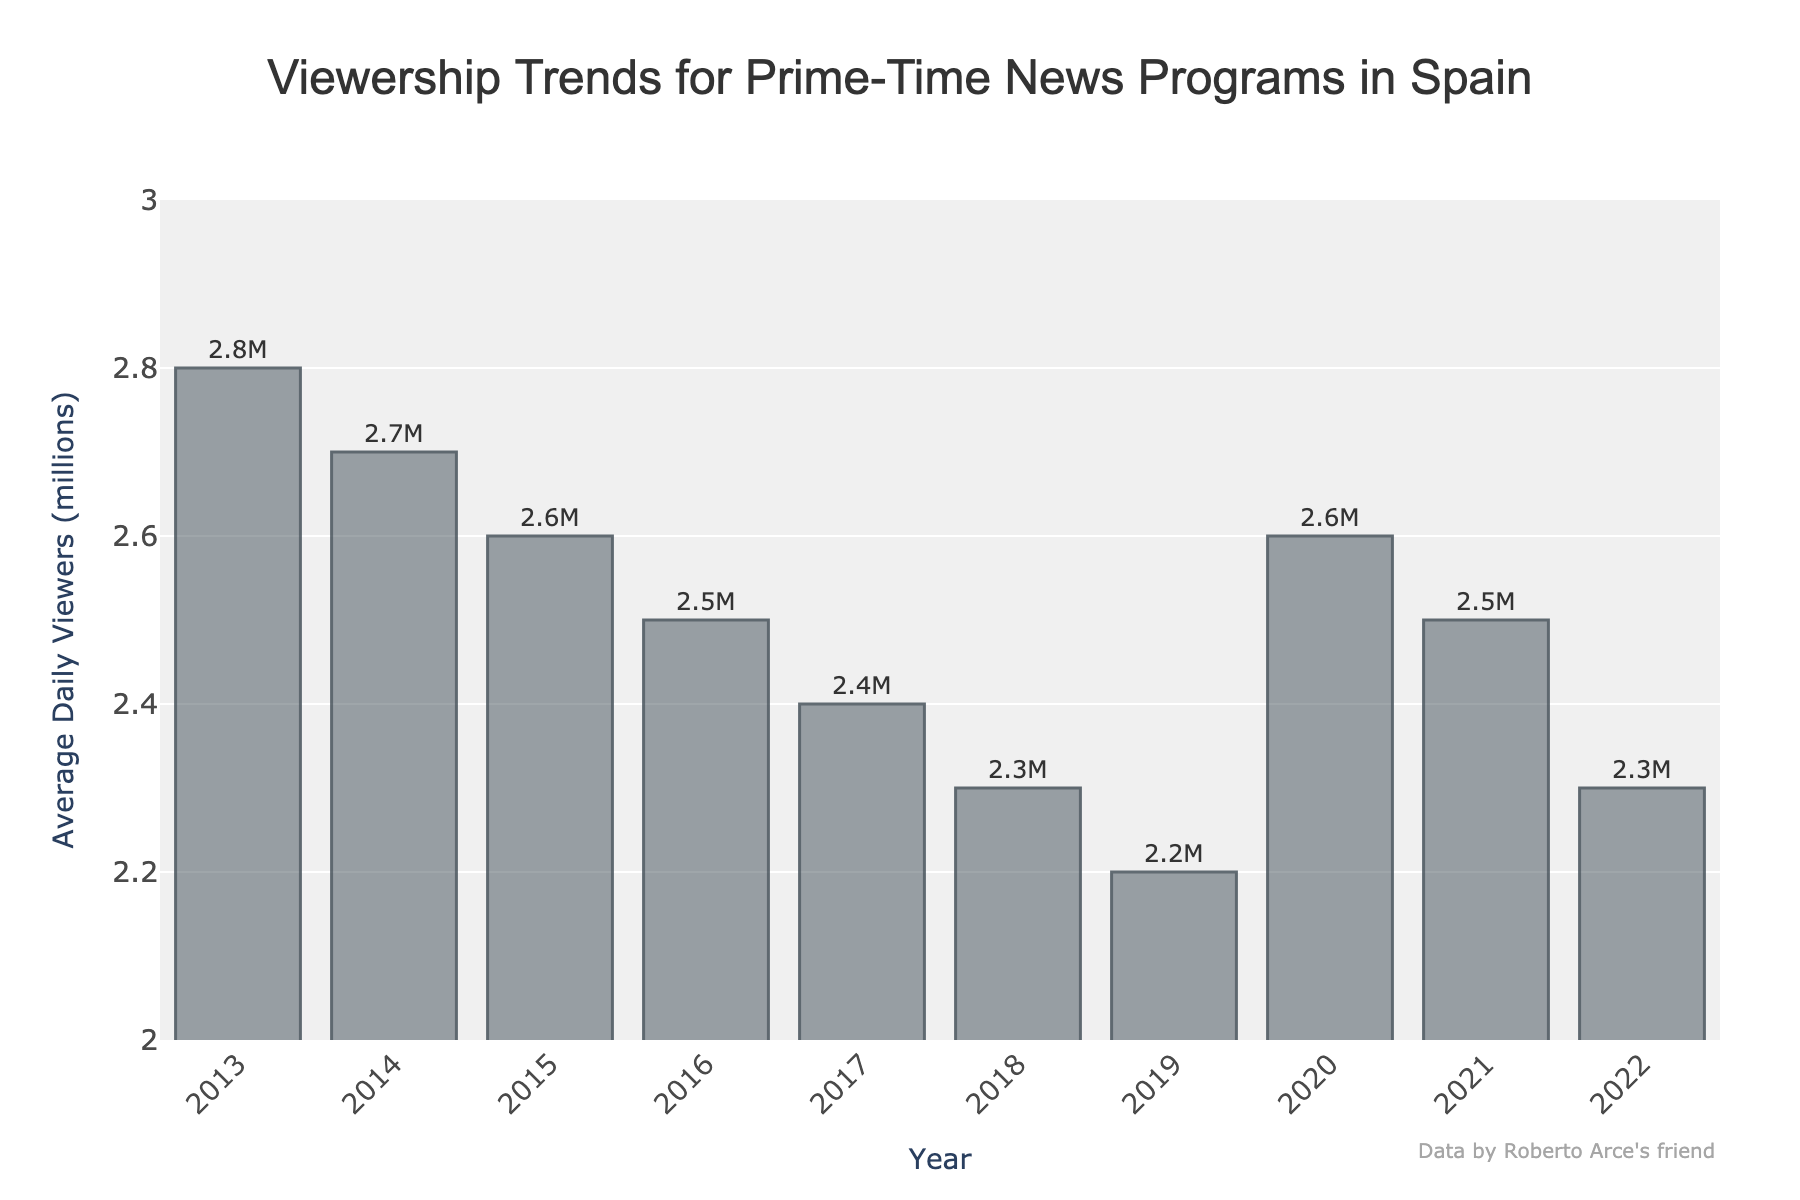what is the average viewership over the past decade? To find the average viewership over the past decade, sum the annual average daily viewers and then divide by the number of years. (2.8 + 2.7 + 2.6 + 2.5 + 2.4 + 2.3 + 2.2 + 2.6 + 2.5 + 2.3) / 10 = 25.9 / 10 = 2.59 million
Answer: 2.59 million Which year had the highest average daily viewers? By visually inspecting the bar heights, the year with the tallest bar represents the highest average daily viewers, which is 2013.
Answer: 2013 How much did the viewership decrease from 2013 to 2019? Subtract the viewership of 2019 from the viewership of 2013. (2.8 - 2.2) = 0.6 million
Answer: 0.6 million Which year saw the most significant increase in viewership? By comparing adjacent bars, the most noticeable increase occurs between 2019 and 2020, where the viewership increased from 2.2 million to 2.6 million.
Answer: 2020 What is the median viewership value for the given years? Order the values and find the middle one. For an even number of observations, it’s the average of the two middle values. Ordered values: [2.2, 2.2, 2.3, 2.3, 2.4, 2.5, 2.5, 2.6, 2.7, 2.8]; two middle values are 2.4 and 2.5, so median is (2.4 + 2.5) / 2 = 2.45 million
Answer: 2.45 million What is the overall trend in viewership from 2013 to 2022? Analyze the general direction of the bars from left (2013) to right (2022). Viewership mostly decreased with a minor resurgence in 2020.
Answer: Decreasing trend Which two consecutive years had the smallest decrease in viewership? By comparing differences between consecutive years, 2021 to 2022 had the smallest decrease (2.5 - 2.3) = 0.2 million
Answer: 2021 to 2022 How many years had a viewership of 2.5 million or more? Count the number of bars with heights equal to or greater than 2.5. The years 2013, 2014, 2015, 2016, 2020, and 2021 qualify. Total = 6 years
Answer: 6 years Based on the bar colors, is there any specific color coding used for different years? All bars exhibit the same color scheme without any distinct variations for different years, indicating a uniform color coding.
Answer: No specific color coding 